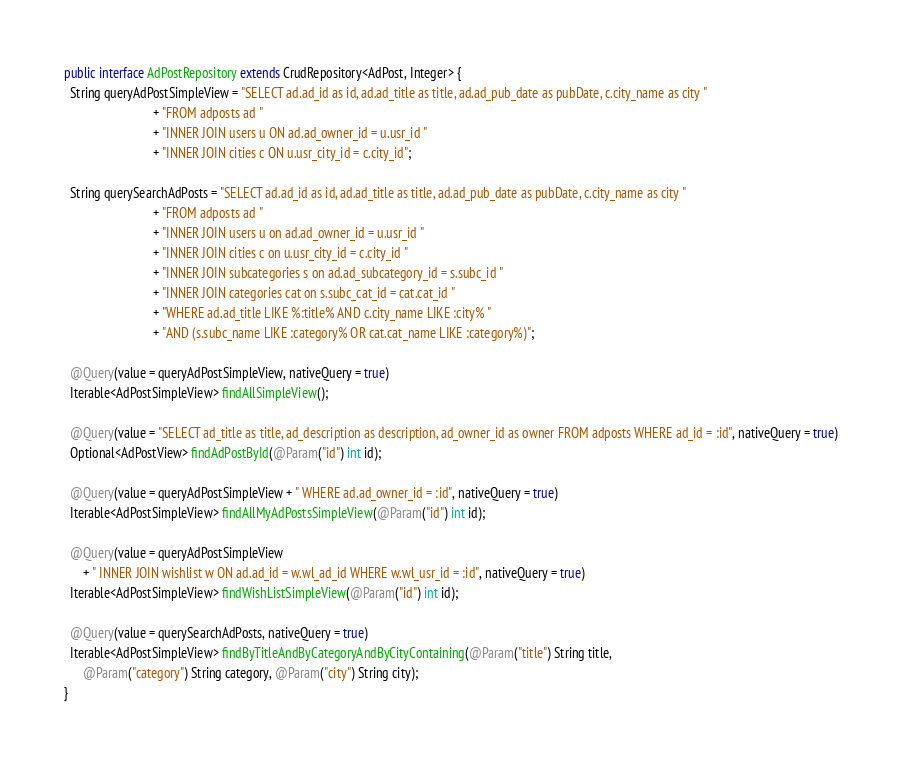<code> <loc_0><loc_0><loc_500><loc_500><_Java_>public interface AdPostRepository extends CrudRepository<AdPost, Integer> {
  String queryAdPostSimpleView = "SELECT ad.ad_id as id, ad.ad_title as title, ad.ad_pub_date as pubDate, c.city_name as city "
                            + "FROM adposts ad "
                            + "INNER JOIN users u ON ad.ad_owner_id = u.usr_id "
                            + "INNER JOIN cities c ON u.usr_city_id = c.city_id";

  String querySearchAdPosts = "SELECT ad.ad_id as id, ad.ad_title as title, ad.ad_pub_date as pubDate, c.city_name as city "
                            + "FROM adposts ad "
                            + "INNER JOIN users u on ad.ad_owner_id = u.usr_id "
                            + "INNER JOIN cities c on u.usr_city_id = c.city_id "
                            + "INNER JOIN subcategories s on ad.ad_subcategory_id = s.subc_id "
                            + "INNER JOIN categories cat on s.subc_cat_id = cat.cat_id "
                            + "WHERE ad.ad_title LIKE %:title% AND c.city_name LIKE :city% "
                            + "AND (s.subc_name LIKE :category% OR cat.cat_name LIKE :category%)";

  @Query(value = queryAdPostSimpleView, nativeQuery = true)
  Iterable<AdPostSimpleView> findAllSimpleView();

  @Query(value = "SELECT ad_title as title, ad_description as description, ad_owner_id as owner FROM adposts WHERE ad_id = :id", nativeQuery = true)
  Optional<AdPostView> findAdPostById(@Param("id") int id);

  @Query(value = queryAdPostSimpleView + " WHERE ad.ad_owner_id = :id", nativeQuery = true)
  Iterable<AdPostSimpleView> findAllMyAdPostsSimpleView(@Param("id") int id);

  @Query(value = queryAdPostSimpleView
      + " INNER JOIN wishlist w ON ad.ad_id = w.wl_ad_id WHERE w.wl_usr_id = :id", nativeQuery = true)
  Iterable<AdPostSimpleView> findWishListSimpleView(@Param("id") int id);

  @Query(value = querySearchAdPosts, nativeQuery = true)
  Iterable<AdPostSimpleView> findByTitleAndByCategoryAndByCityContaining(@Param("title") String title,
      @Param("category") String category, @Param("city") String city);
}
</code> 